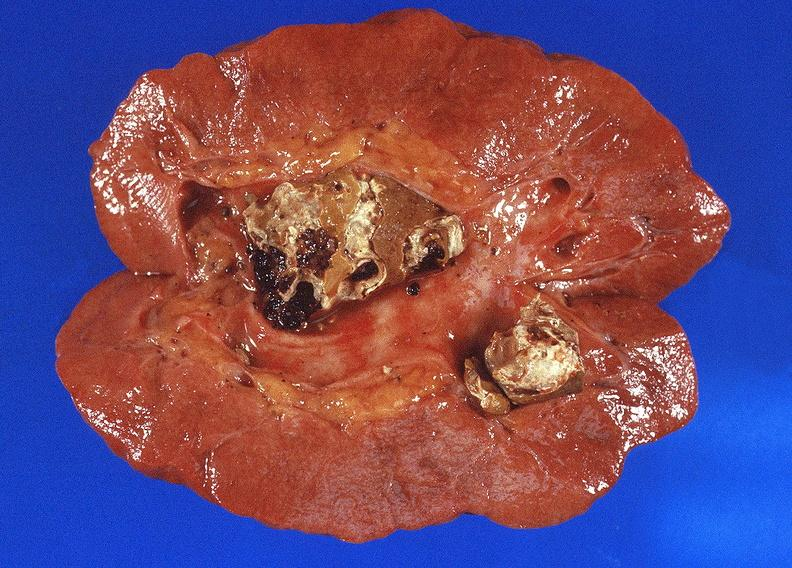where is this?
Answer the question using a single word or phrase. Urinary 